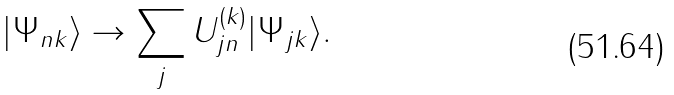Convert formula to latex. <formula><loc_0><loc_0><loc_500><loc_500>| \Psi _ { n { k } } \rangle \to \sum _ { j } U ^ { ( { k } ) } _ { j n } | \Psi _ { j { k } } \rangle .</formula> 